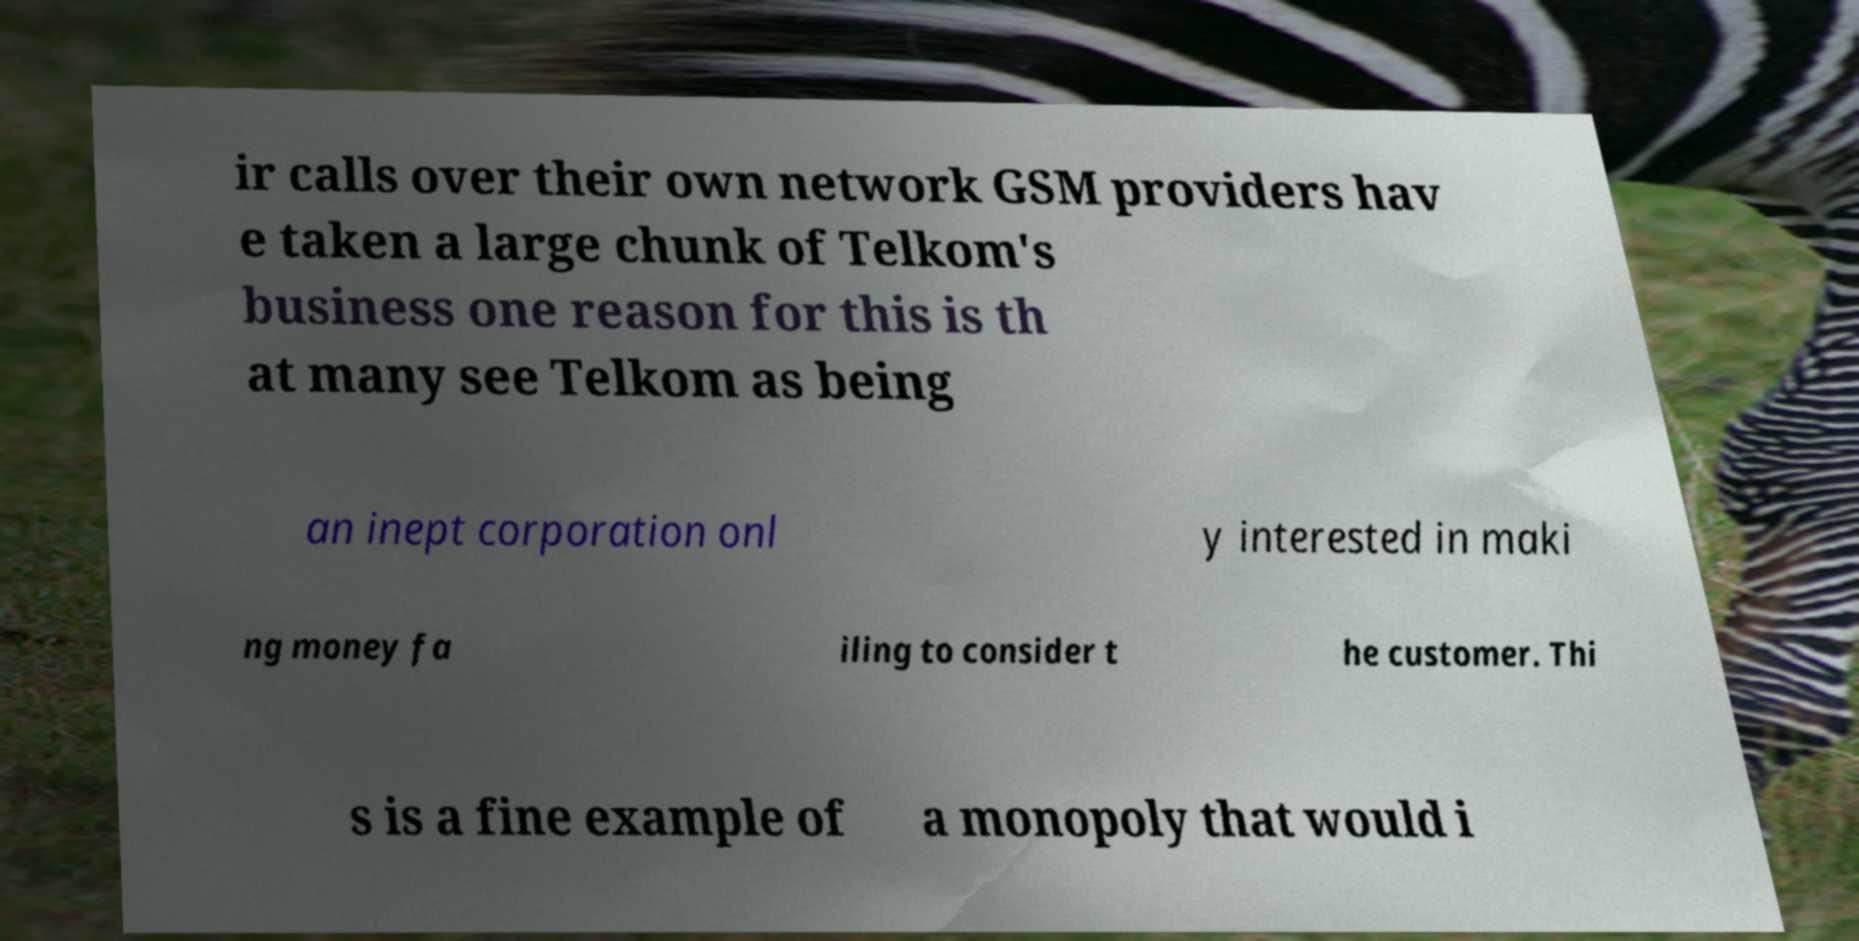There's text embedded in this image that I need extracted. Can you transcribe it verbatim? ir calls over their own network GSM providers hav e taken a large chunk of Telkom's business one reason for this is th at many see Telkom as being an inept corporation onl y interested in maki ng money fa iling to consider t he customer. Thi s is a fine example of a monopoly that would i 